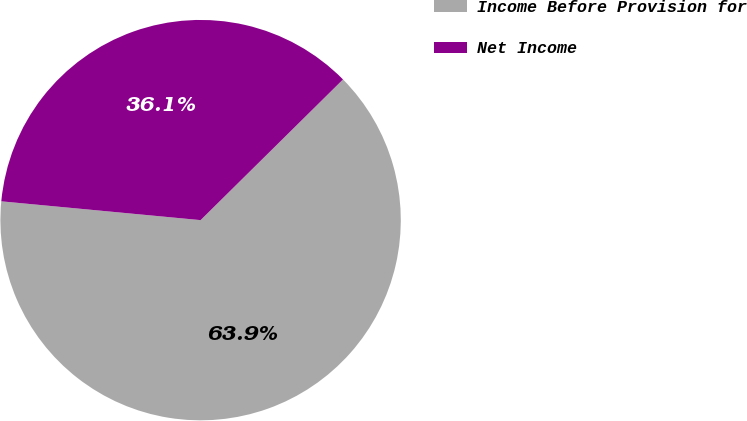<chart> <loc_0><loc_0><loc_500><loc_500><pie_chart><fcel>Income Before Provision for<fcel>Net Income<nl><fcel>63.9%<fcel>36.1%<nl></chart> 